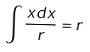<formula> <loc_0><loc_0><loc_500><loc_500>\int \frac { x d x } { r } = r</formula> 